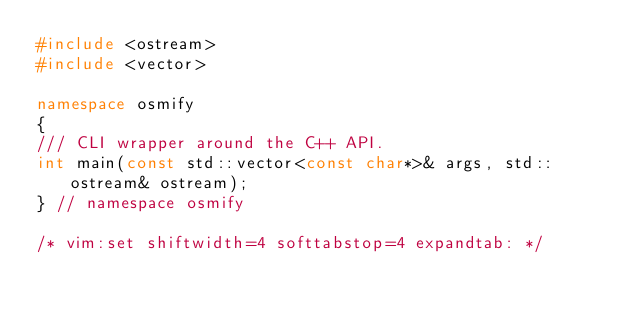Convert code to text. <code><loc_0><loc_0><loc_500><loc_500><_C++_>#include <ostream>
#include <vector>

namespace osmify
{
/// CLI wrapper around the C++ API.
int main(const std::vector<const char*>& args, std::ostream& ostream);
} // namespace osmify

/* vim:set shiftwidth=4 softtabstop=4 expandtab: */
</code> 